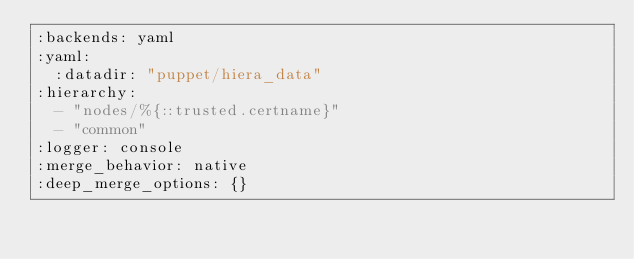Convert code to text. <code><loc_0><loc_0><loc_500><loc_500><_YAML_>:backends: yaml
:yaml:
  :datadir: "puppet/hiera_data"
:hierarchy:
  - "nodes/%{::trusted.certname}"
  - "common"
:logger: console
:merge_behavior: native
:deep_merge_options: {}
</code> 